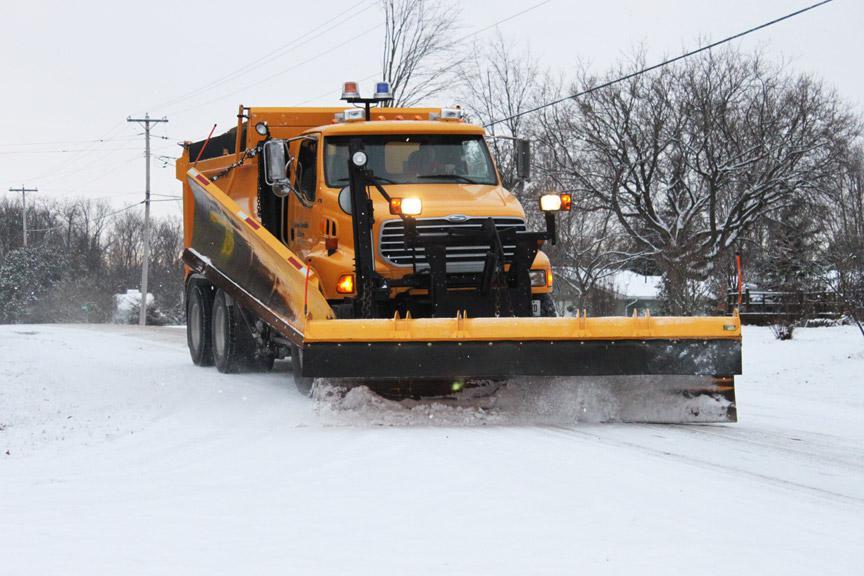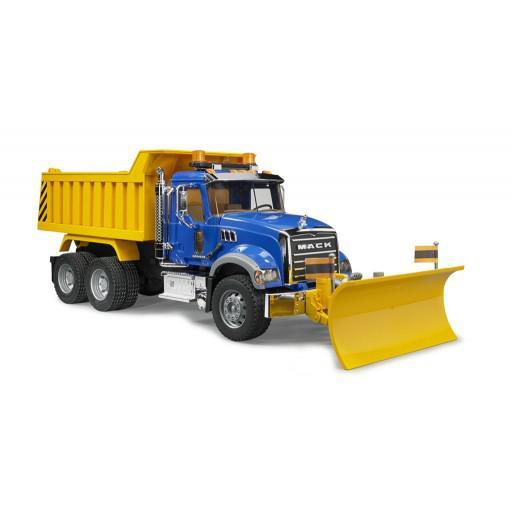The first image is the image on the left, the second image is the image on the right. Assess this claim about the two images: "One image shows just one truck with a solid orange plow.". Correct or not? Answer yes or no. No. 